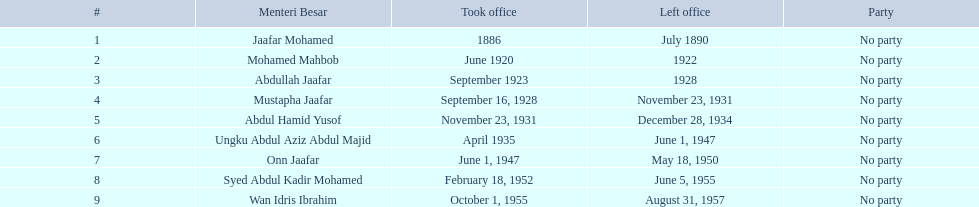When did jaafar mohamed take office? 1886. When did mohamed mahbob take office? June 1920. Who was in office no more than 4 years? Mohamed Mahbob. 